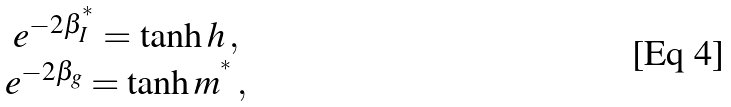Convert formula to latex. <formula><loc_0><loc_0><loc_500><loc_500>\begin{array} { c } e ^ { - 2 \beta _ { I } ^ { ^ { * } } } = \tanh h \, , \\ e ^ { - 2 \beta _ { g } } = \tanh m ^ { ^ { * } } \, , \end{array}</formula> 